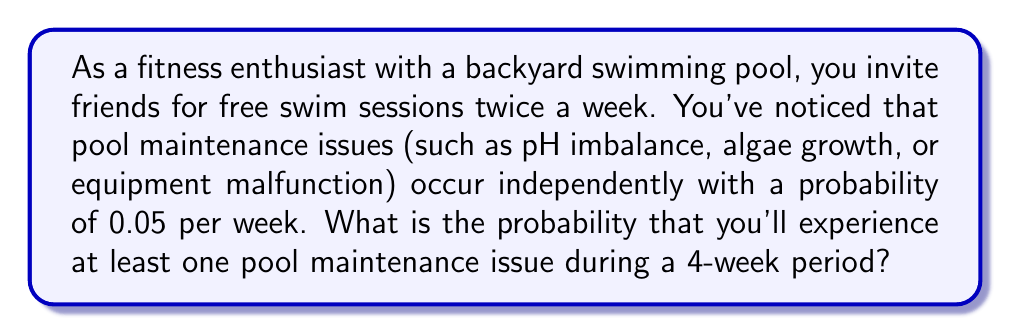Solve this math problem. To solve this problem, we'll use the complement rule of probability. Instead of calculating the probability of at least one issue occurring, we'll calculate the probability of no issues occurring and subtract that from 1.

Let's break it down step-by-step:

1) First, let's calculate the probability of no issues occurring in one week:
   $P(\text{no issues in 1 week}) = 1 - 0.05 = 0.95$

2) Since the issues occur independently, we can use the multiplication rule of probability for independent events. For no issues to occur in 4 weeks, we need no issues in week 1 AND no issues in week 2 AND no issues in week 3 AND no issues in week 4:

   $P(\text{no issues in 4 weeks}) = 0.95 \times 0.95 \times 0.95 \times 0.95 = 0.95^4$

3) We can calculate this:
   $0.95^4 \approx 0.8145$

4) Now, we use the complement rule. The probability of at least one issue occurring is:

   $P(\text{at least one issue in 4 weeks}) = 1 - P(\text{no issues in 4 weeks})$
   $= 1 - 0.8145 \approx 0.1855$

5) Convert to a percentage:
   $0.1855 \times 100\% \approx 18.55\%$

Therefore, the probability of experiencing at least one pool maintenance issue during a 4-week period is approximately 18.55%.
Answer: $$P(\text{at least one issue in 4 weeks}) \approx 0.1855 \text{ or } 18.55\%$$ 